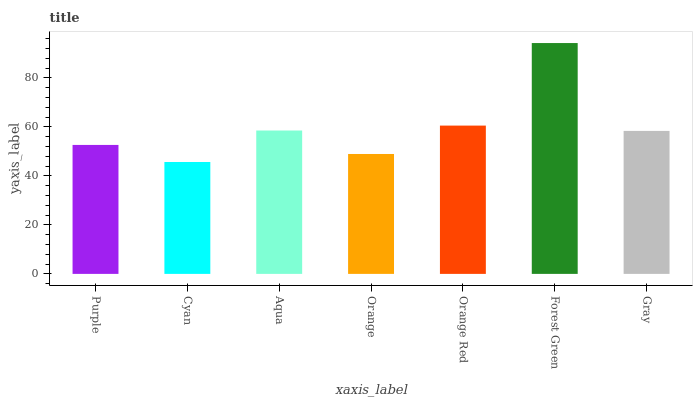Is Cyan the minimum?
Answer yes or no. Yes. Is Forest Green the maximum?
Answer yes or no. Yes. Is Aqua the minimum?
Answer yes or no. No. Is Aqua the maximum?
Answer yes or no. No. Is Aqua greater than Cyan?
Answer yes or no. Yes. Is Cyan less than Aqua?
Answer yes or no. Yes. Is Cyan greater than Aqua?
Answer yes or no. No. Is Aqua less than Cyan?
Answer yes or no. No. Is Gray the high median?
Answer yes or no. Yes. Is Gray the low median?
Answer yes or no. Yes. Is Aqua the high median?
Answer yes or no. No. Is Orange the low median?
Answer yes or no. No. 